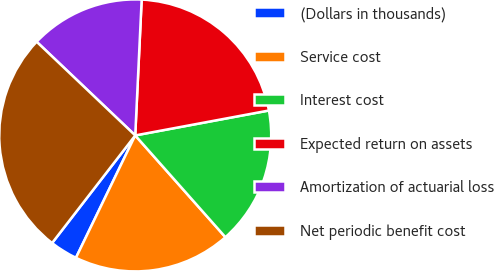Convert chart to OTSL. <chart><loc_0><loc_0><loc_500><loc_500><pie_chart><fcel>(Dollars in thousands)<fcel>Service cost<fcel>Interest cost<fcel>Expected return on assets<fcel>Amortization of actuarial loss<fcel>Net periodic benefit cost<nl><fcel>3.29%<fcel>18.72%<fcel>16.39%<fcel>21.31%<fcel>13.66%<fcel>26.62%<nl></chart> 